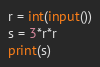<code> <loc_0><loc_0><loc_500><loc_500><_Python_>r = int(input())
s = 3*r*r
print(s)</code> 